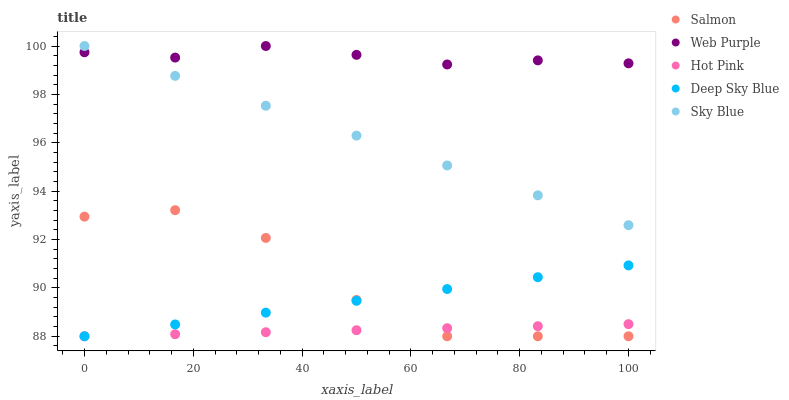Does Hot Pink have the minimum area under the curve?
Answer yes or no. Yes. Does Web Purple have the maximum area under the curve?
Answer yes or no. Yes. Does Web Purple have the minimum area under the curve?
Answer yes or no. No. Does Hot Pink have the maximum area under the curve?
Answer yes or no. No. Is Hot Pink the smoothest?
Answer yes or no. Yes. Is Salmon the roughest?
Answer yes or no. Yes. Is Web Purple the smoothest?
Answer yes or no. No. Is Web Purple the roughest?
Answer yes or no. No. Does Hot Pink have the lowest value?
Answer yes or no. Yes. Does Web Purple have the lowest value?
Answer yes or no. No. Does Web Purple have the highest value?
Answer yes or no. Yes. Does Hot Pink have the highest value?
Answer yes or no. No. Is Hot Pink less than Web Purple?
Answer yes or no. Yes. Is Web Purple greater than Salmon?
Answer yes or no. Yes. Does Salmon intersect Deep Sky Blue?
Answer yes or no. Yes. Is Salmon less than Deep Sky Blue?
Answer yes or no. No. Is Salmon greater than Deep Sky Blue?
Answer yes or no. No. Does Hot Pink intersect Web Purple?
Answer yes or no. No. 